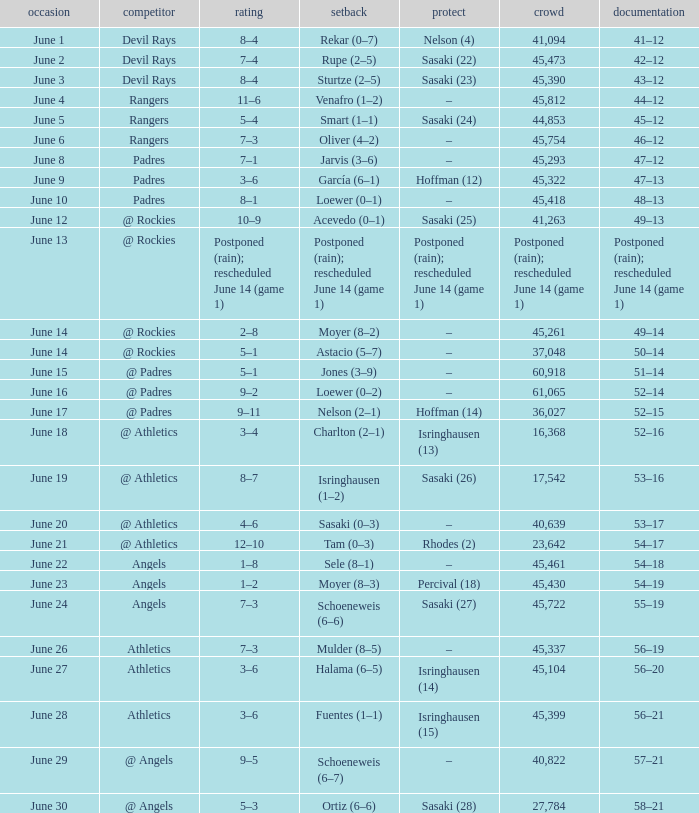What was the attendance of the Mariners game when they had a record of 56–20? 45104.0. 